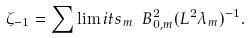Convert formula to latex. <formula><loc_0><loc_0><loc_500><loc_500>\zeta _ { - 1 } = \sum \lim i t s _ { m } \ B _ { 0 , m } ^ { 2 } ( L ^ { 2 } \lambda _ { m } ) ^ { - 1 } .</formula> 